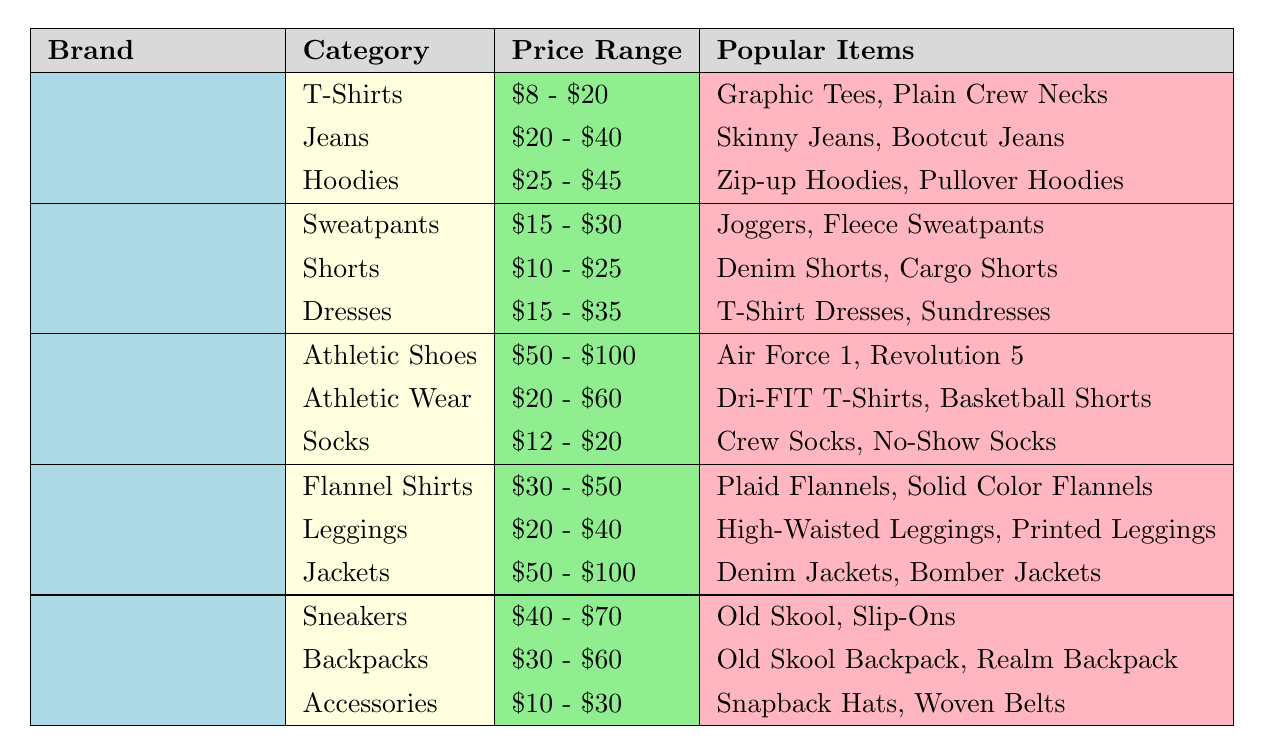What’s the price range for T-Shirts from Old Navy? The T-Shirts category for Old Navy has a listed price range of $8 - $20 directly in the table.
Answer: $8 - $20 Which brand offers athletic shoes at the highest price range? Looking at the table, Nike's athletic shoes have the price range of $50 - $100, which is the highest compared to other brands.
Answer: Nike How many categories does American Eagle have, and what are they? American Eagle has three categories: Flannel Shirts, Leggings, and Jackets, as listed in the table.
Answer: Three categories What is the price range for the most expensive item type in H&M? The most expensive item type in H&M is Dresses, with a price range of $15 - $35 noted in the table. Compare this with other categories to confirm its highest value.
Answer: $15 - $35 Are there any brands that sell accessories for less than $10? Reviewing the table, the lowest price range for Accessories is $10 - $30 from Vans; therefore, no brand sells accessories for less than $10.
Answer: No What is the average price range for jeans across the brands listed? Old Navy's jeans range from $20 - $40, while no other brands specifically mention jeans. The average price range cannot be calculated precisely; thus, we take Old Navy's value into account.
Answer: $20 - $40 Which brand has the widest price range for their clothing categories? Nike has the widest price range with Athletic Shoes ($50 - $100), Athletic Wear ($20 - $60), and Socks ($12 - $20). Calculate the differences: 100 - 12 = 88.
Answer: Nike If I want to buy two pairs of socks from Nike, what would be the minimum I would pay? The price range for Nike's socks is $12 - $20. To find the minimum for two pairs, we calculate it as 2 * $12.
Answer: $24 What types of popular items are available under Hoodies from Old Navy? According to the table, the popular items listed under Hoodies from Old Navy are Zip-up Hoodies and Pullover Hoodies.
Answer: Zip-up Hoodies, Pullover Hoodies Which brand has the least expensive shorts? H&M offers shorts in the price range of $10 - $25, which is lower than what other brands show for shorts, indicating it as the least expensive option.
Answer: H&M 